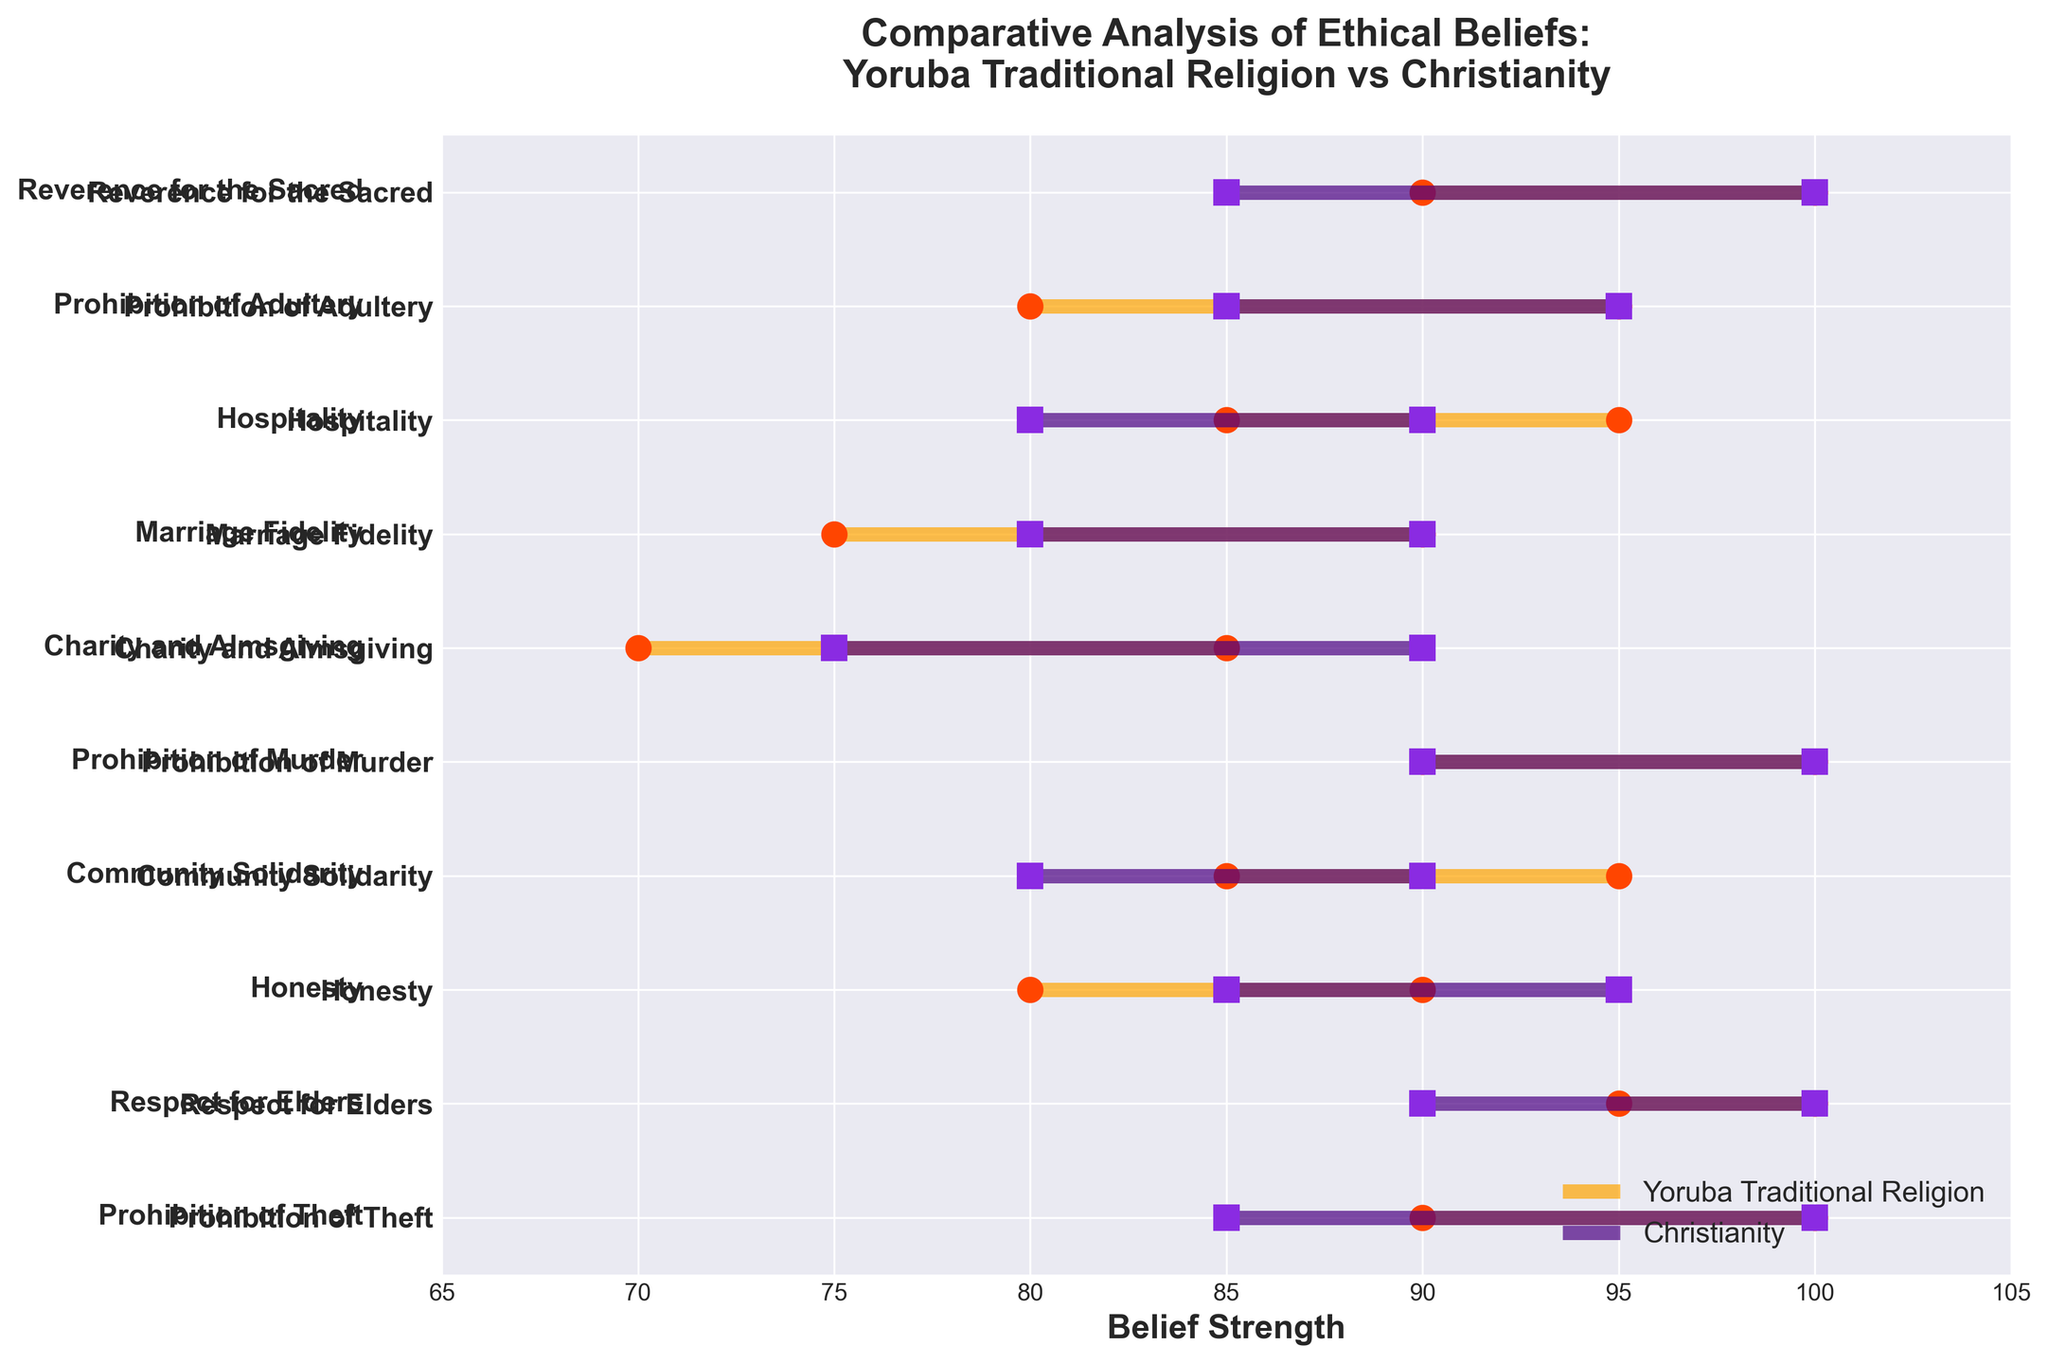What are the ranges of belief strengths for the "Respect for Elders" concept in both Yoruba Traditional Religion and Christianity? The range of belief strength for "Respect for Elders" in Yoruba Traditional Religion is 95-100, while in Christianity it is 90-100.
Answer: Yoruba: 95-100, Christianity: 90-100 Which ethical concept has the lowest minimum belief strength in Yoruba Traditional Religion? The concept with the lowest minimum belief strength in Yoruba Traditional Religion is "Charity and Almsgiving" with a minimum value of 70.
Answer: Charity and Almsgiving How do the ranges of belief strengths for "Honesty" compare between Yoruba Traditional Religion and Christianity? For "Honesty," Yoruba Traditional Religion has a range of 80-90, while Christianity has a range of 85-95. This shows that the range in Christianity is generally higher.
Answer: Yoruba: 80-90, Christianity: 85-95 Which ethical concept has the same range of belief strengths for both Yoruba Traditional Religion and Christianity? The concept “Prohibition of Murder” has the same range of belief strengths in both Yoruba Traditional Religion and Christianity, which is 90-100.
Answer: Prohibition of Murder What is the average of the minimum values for the "Marriage Fidelity" concept across both religions? The minimum value for Marriage Fidelity in Yoruba Traditional Religion is 75, and in Christianity, it is 80. The average of these values is (75 + 80) / 2 = 77.5.
Answer: 77.5 Which ethical concept shows a wider range in Christianity compared to Yoruba Traditional Religion? "Charity and Almsgiving" shows a wider range in Christianity (75-90, range of 15) compared to Yoruba Traditional Religion (70-85, range of 15), so their ranges are the same. Since the range values are equal, no ethical concept shows a wider range in Christianity.
Answer: None For the concept "Community Solidarity," which religion has the higher maximum belief strength? The maximum belief strength for "Community Solidarity" in Yoruba Traditional Religion is 95, while in Christianity it is 90. Hence, Yoruba Traditional Religion has the higher maximum value.
Answer: Yoruba Traditional Religion Which ethical concept shows the smallest range in Yoruba Traditional Religion? The concept "Prohibition of Theft" has the smallest range in Yoruba Traditional Religion, with both the minimum and maximum values being 90-100, a range of 10.
Answer: Prohibition of Theft 